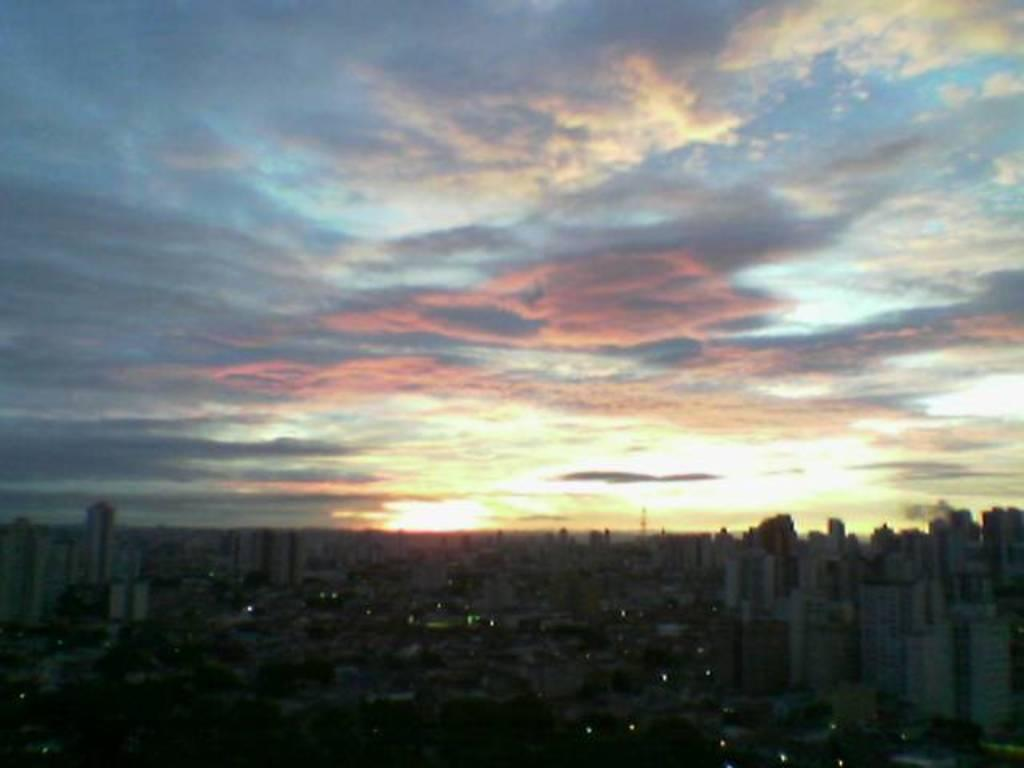What type of view is shown in the image? The image is taken from an aerial view of a city. What can be seen in the image from this perspective? There are many buildings in the image. What is visible in the sky in the image? The sky is visible in the image, and clouds are present. How many bikes can be seen parked near the buildings in the image? There are no bikes visible in the image; it shows an aerial view of a city with many buildings and clouds in the sky. 